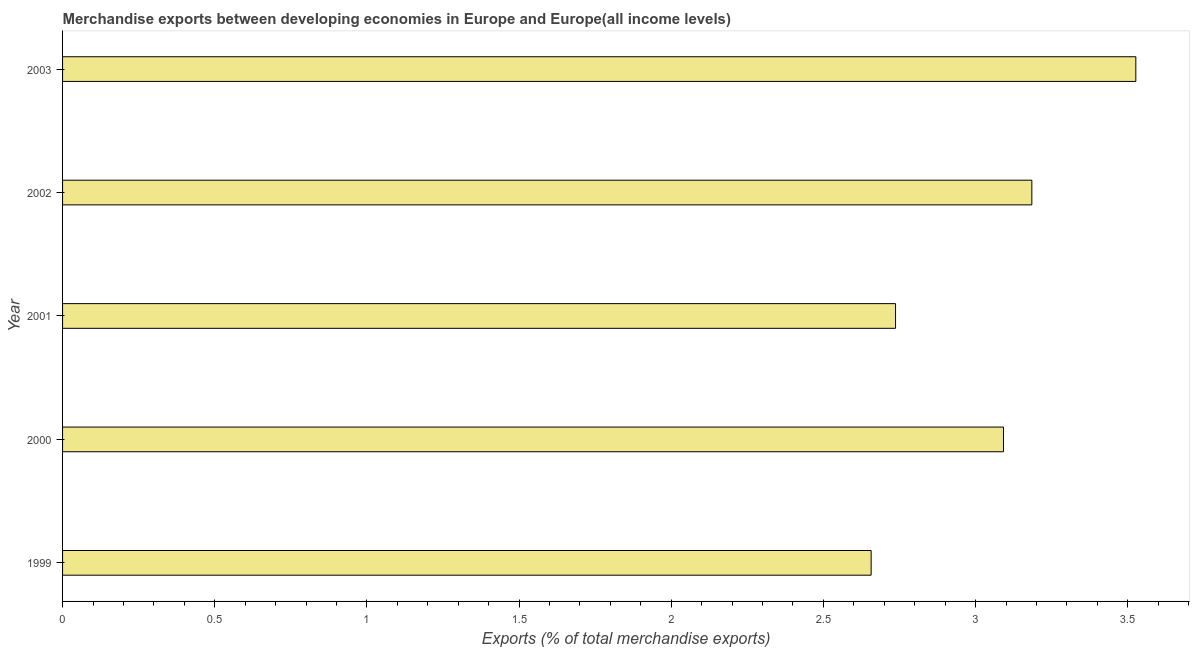Does the graph contain any zero values?
Give a very brief answer. No. What is the title of the graph?
Offer a very short reply. Merchandise exports between developing economies in Europe and Europe(all income levels). What is the label or title of the X-axis?
Your answer should be compact. Exports (% of total merchandise exports). What is the merchandise exports in 2001?
Offer a very short reply. 2.74. Across all years, what is the maximum merchandise exports?
Keep it short and to the point. 3.53. Across all years, what is the minimum merchandise exports?
Provide a short and direct response. 2.66. In which year was the merchandise exports minimum?
Make the answer very short. 1999. What is the sum of the merchandise exports?
Your answer should be compact. 15.2. What is the difference between the merchandise exports in 2001 and 2002?
Provide a succinct answer. -0.45. What is the average merchandise exports per year?
Make the answer very short. 3.04. What is the median merchandise exports?
Provide a succinct answer. 3.09. Do a majority of the years between 2003 and 2000 (inclusive) have merchandise exports greater than 1.4 %?
Provide a short and direct response. Yes. What is the ratio of the merchandise exports in 2001 to that in 2003?
Your answer should be compact. 0.78. What is the difference between the highest and the second highest merchandise exports?
Keep it short and to the point. 0.34. Is the sum of the merchandise exports in 1999 and 2001 greater than the maximum merchandise exports across all years?
Your response must be concise. Yes. What is the difference between the highest and the lowest merchandise exports?
Make the answer very short. 0.87. In how many years, is the merchandise exports greater than the average merchandise exports taken over all years?
Your response must be concise. 3. How many bars are there?
Offer a very short reply. 5. Are all the bars in the graph horizontal?
Your response must be concise. Yes. What is the difference between two consecutive major ticks on the X-axis?
Offer a very short reply. 0.5. Are the values on the major ticks of X-axis written in scientific E-notation?
Offer a very short reply. No. What is the Exports (% of total merchandise exports) in 1999?
Provide a short and direct response. 2.66. What is the Exports (% of total merchandise exports) of 2000?
Your answer should be very brief. 3.09. What is the Exports (% of total merchandise exports) of 2001?
Your answer should be compact. 2.74. What is the Exports (% of total merchandise exports) of 2002?
Provide a short and direct response. 3.18. What is the Exports (% of total merchandise exports) of 2003?
Offer a very short reply. 3.53. What is the difference between the Exports (% of total merchandise exports) in 1999 and 2000?
Keep it short and to the point. -0.43. What is the difference between the Exports (% of total merchandise exports) in 1999 and 2001?
Your answer should be very brief. -0.08. What is the difference between the Exports (% of total merchandise exports) in 1999 and 2002?
Make the answer very short. -0.53. What is the difference between the Exports (% of total merchandise exports) in 1999 and 2003?
Your response must be concise. -0.87. What is the difference between the Exports (% of total merchandise exports) in 2000 and 2001?
Your answer should be very brief. 0.35. What is the difference between the Exports (% of total merchandise exports) in 2000 and 2002?
Offer a very short reply. -0.09. What is the difference between the Exports (% of total merchandise exports) in 2000 and 2003?
Keep it short and to the point. -0.43. What is the difference between the Exports (% of total merchandise exports) in 2001 and 2002?
Ensure brevity in your answer.  -0.45. What is the difference between the Exports (% of total merchandise exports) in 2001 and 2003?
Give a very brief answer. -0.79. What is the difference between the Exports (% of total merchandise exports) in 2002 and 2003?
Your answer should be very brief. -0.34. What is the ratio of the Exports (% of total merchandise exports) in 1999 to that in 2000?
Offer a very short reply. 0.86. What is the ratio of the Exports (% of total merchandise exports) in 1999 to that in 2002?
Your answer should be very brief. 0.83. What is the ratio of the Exports (% of total merchandise exports) in 1999 to that in 2003?
Make the answer very short. 0.75. What is the ratio of the Exports (% of total merchandise exports) in 2000 to that in 2001?
Your response must be concise. 1.13. What is the ratio of the Exports (% of total merchandise exports) in 2000 to that in 2002?
Give a very brief answer. 0.97. What is the ratio of the Exports (% of total merchandise exports) in 2000 to that in 2003?
Your answer should be very brief. 0.88. What is the ratio of the Exports (% of total merchandise exports) in 2001 to that in 2002?
Keep it short and to the point. 0.86. What is the ratio of the Exports (% of total merchandise exports) in 2001 to that in 2003?
Provide a succinct answer. 0.78. What is the ratio of the Exports (% of total merchandise exports) in 2002 to that in 2003?
Keep it short and to the point. 0.9. 